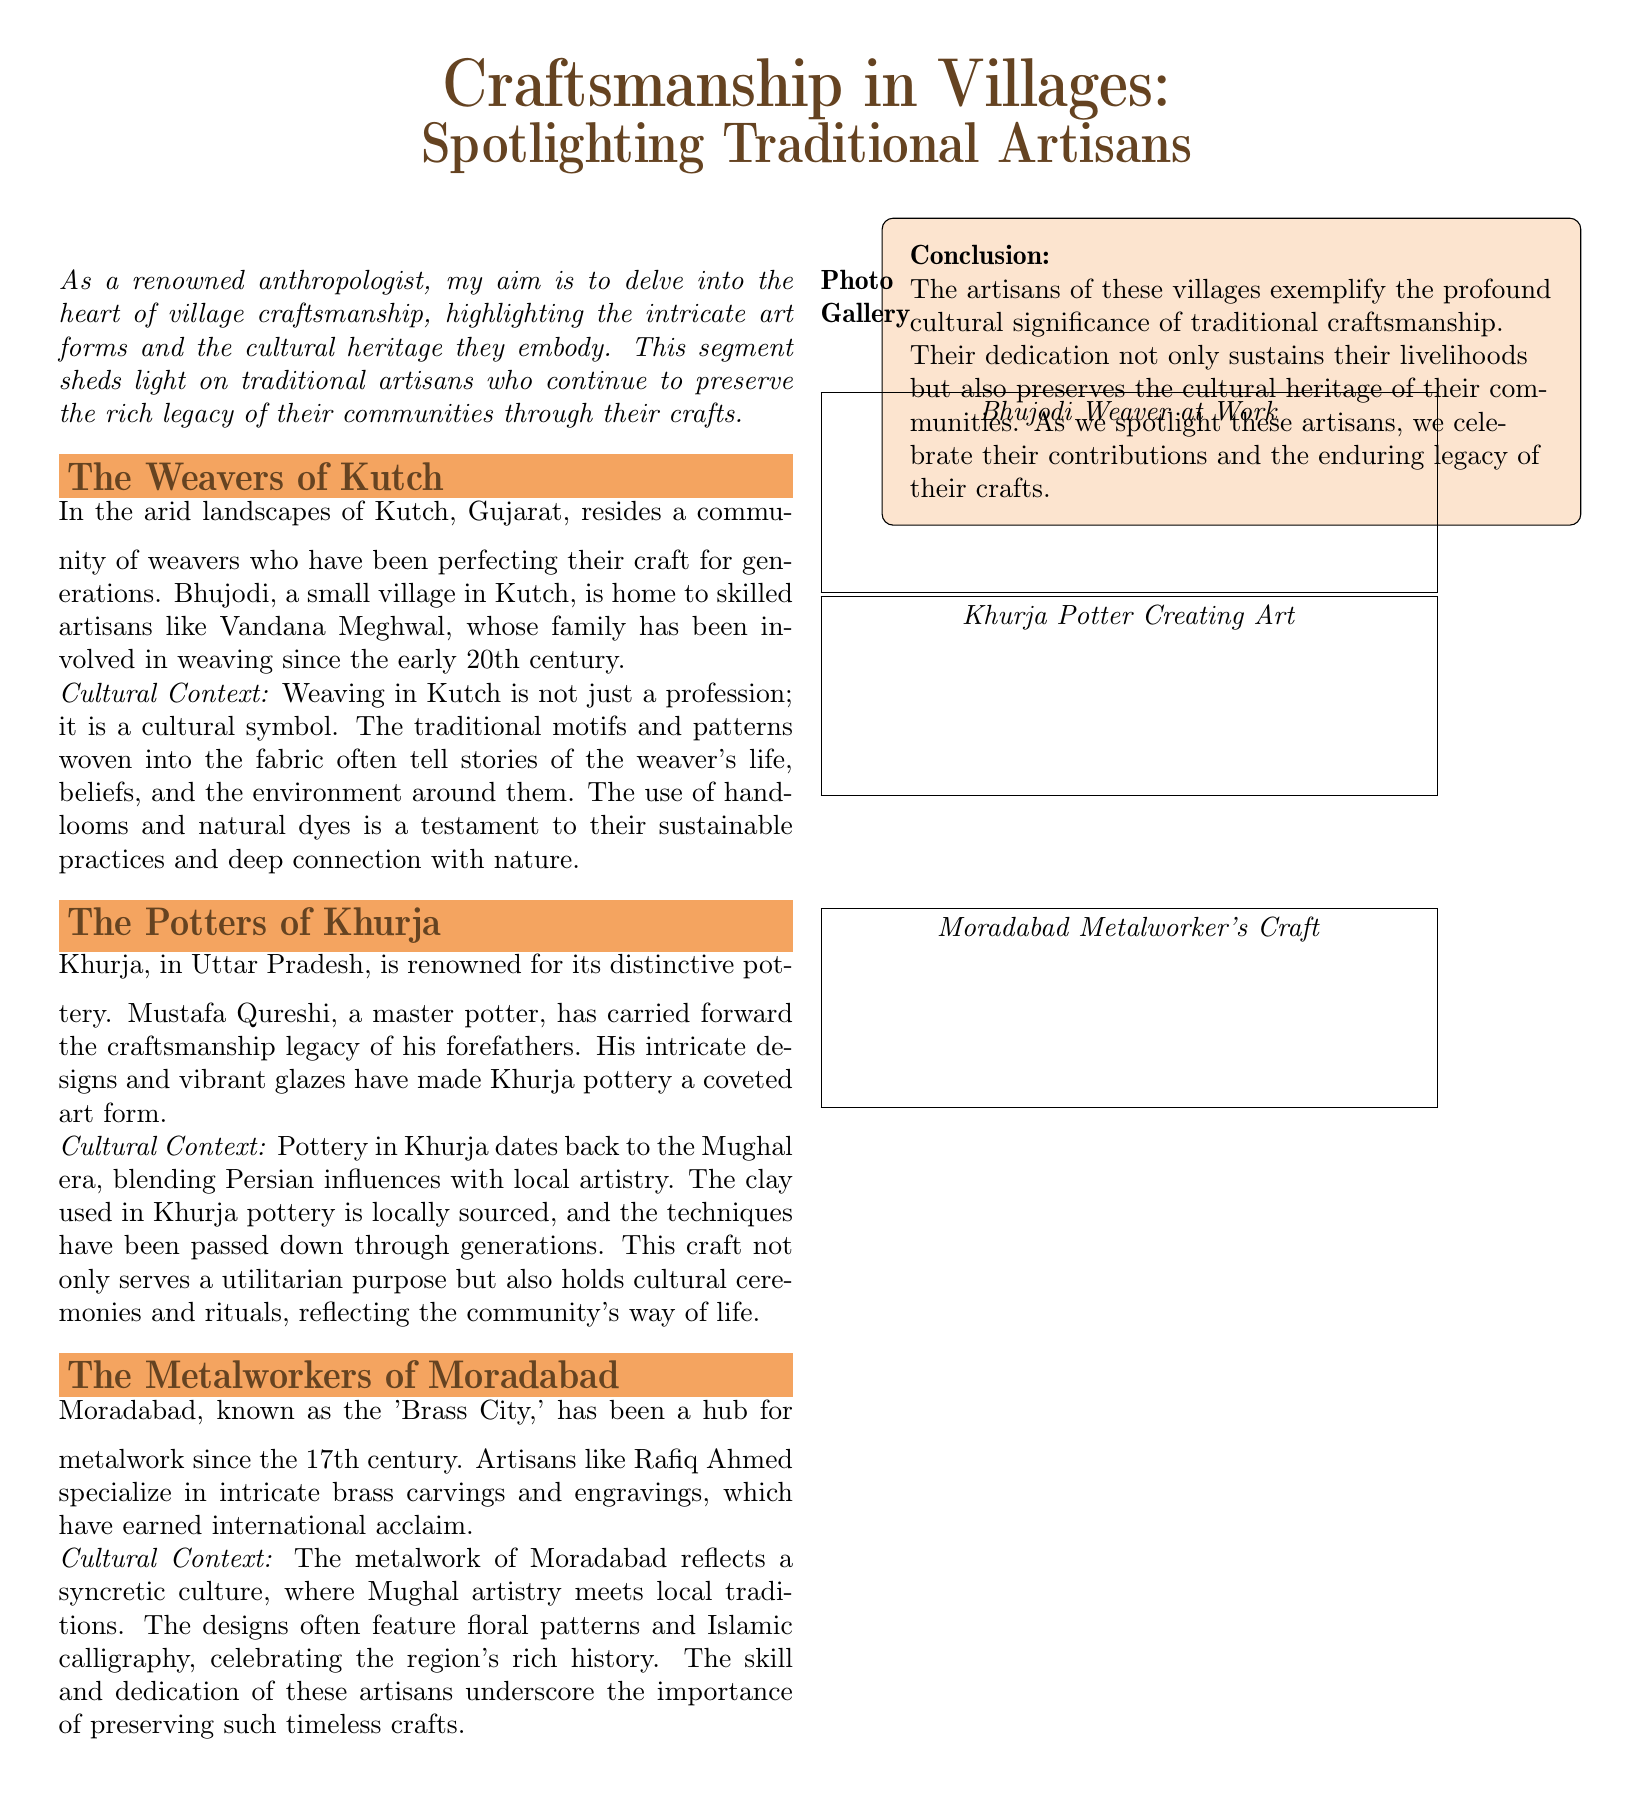what is the name of the community featured in Kutch? The document mentions a community of weavers who have been perfecting their craft in Kutch, specifically the Bhujodi village.
Answer: Bhujodi who is the master potter from Khurja? Mustafa Qureshi is highlighted as the master potter who continues the craftsmanship legacy in Khurja.
Answer: Mustafa Qureshi what is the cultural significance of weaving in Kutch? Weaving in Kutch is described as a cultural symbol, where traditional motifs tell stories of the weaver's life and the environment.
Answer: Cultural symbol which city is known as the 'Brass City'? The city known as the 'Brass City' is Moradabad, recognized for its metalwork.
Answer: Moradabad what type of artistry influences the pottery in Khurja? The pottery in Khurja reflects influences from the Mughal era, blending Persian artistry with local styles.
Answer: Mughal era how many artisans are featured in the document? The document highlights three artisans: Vandana Meghwal, Mustafa Qureshi, and Rafiq Ahmed.
Answer: Three what is the primary material used in Khurja pottery? The primary material used in Khurja pottery is locally sourced clay.
Answer: Clay what is the purpose of the designs in Moradabad metalwork? The designs in Moradabad metalwork often feature floral patterns and Islamic calligraphy, celebrating cultural heritage.
Answer: Cultural heritage what is the conclusion about the artisans mentioned? The conclusion states that the artisans exemplify the cultural significance of traditional craftsmanship and contribute to preserving cultural heritage.
Answer: Cultural significance 